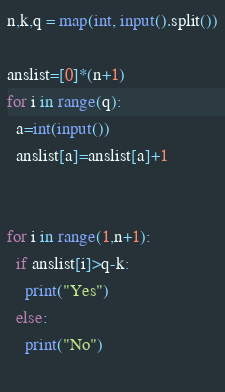Convert code to text. <code><loc_0><loc_0><loc_500><loc_500><_Python_>n,k,q = map(int, input().split())

anslist=[0]*(n+1)
for i in range(q):
  a=int(input())
  anslist[a]=anslist[a]+1

  
for i in range(1,n+1):
  if anslist[i]>q-k:
    print("Yes")
  else:
    print("No")
    </code> 